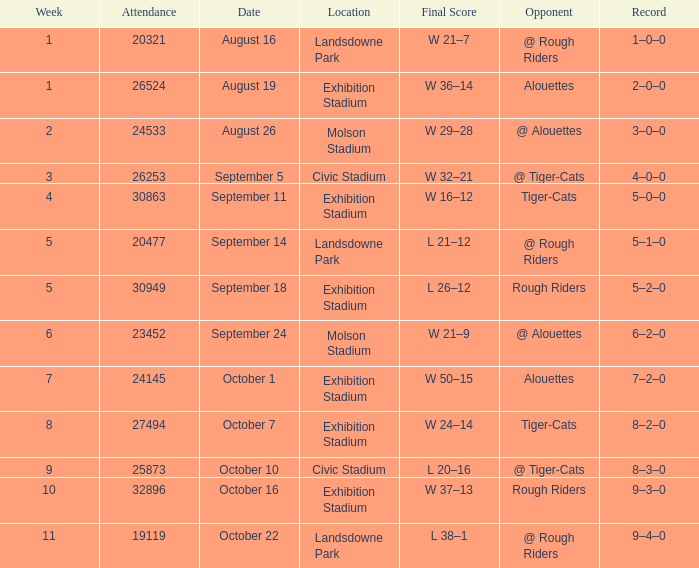How many dates for the week of 4? 1.0. 